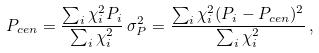Convert formula to latex. <formula><loc_0><loc_0><loc_500><loc_500>P _ { c e n } = \frac { \sum _ { i } \chi ^ { 2 } _ { i } P _ { i } } { \sum _ { i } \chi ^ { 2 } _ { i } } \, \sigma ^ { 2 } _ { P } = \frac { \sum _ { i } \chi ^ { 2 } _ { i } ( P _ { i } - P _ { c e n } ) ^ { 2 } } { \sum _ { i } \chi ^ { 2 } _ { i } } \, ,</formula> 